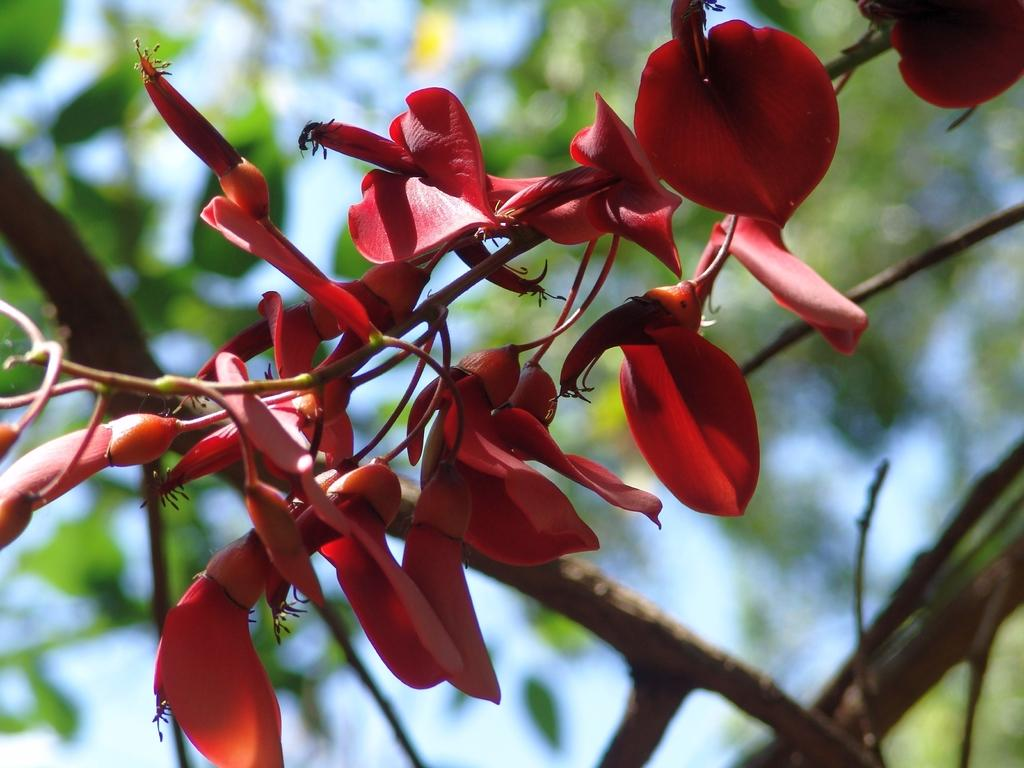What type of flowers can be seen in the image? There are red flowers in the image. How would you describe the background of the image? The background is blurred. What other plant elements are visible in the image besides the flowers? Green leaves and green stems are visible in the image. Can you find the key that is hidden among the red flowers in the image? There is no key present in the image; it only features red flowers, green leaves, and green stems. 